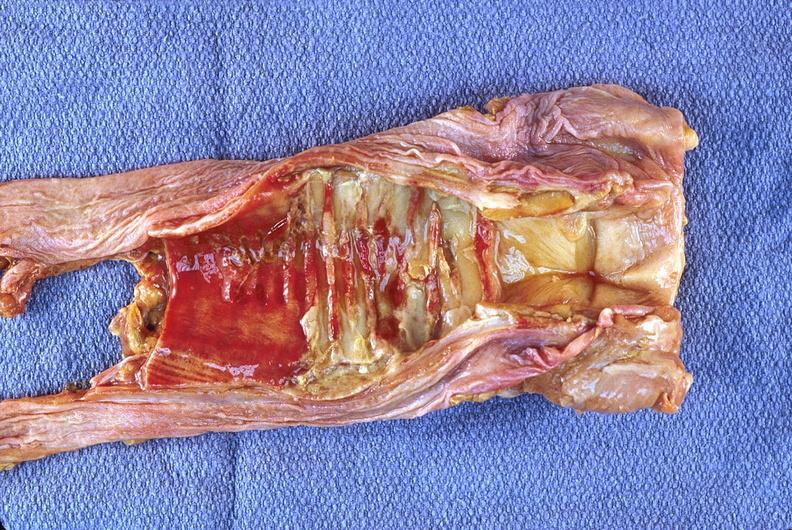does this image show trachea, necrotizing tracheitis?
Answer the question using a single word or phrase. Yes 